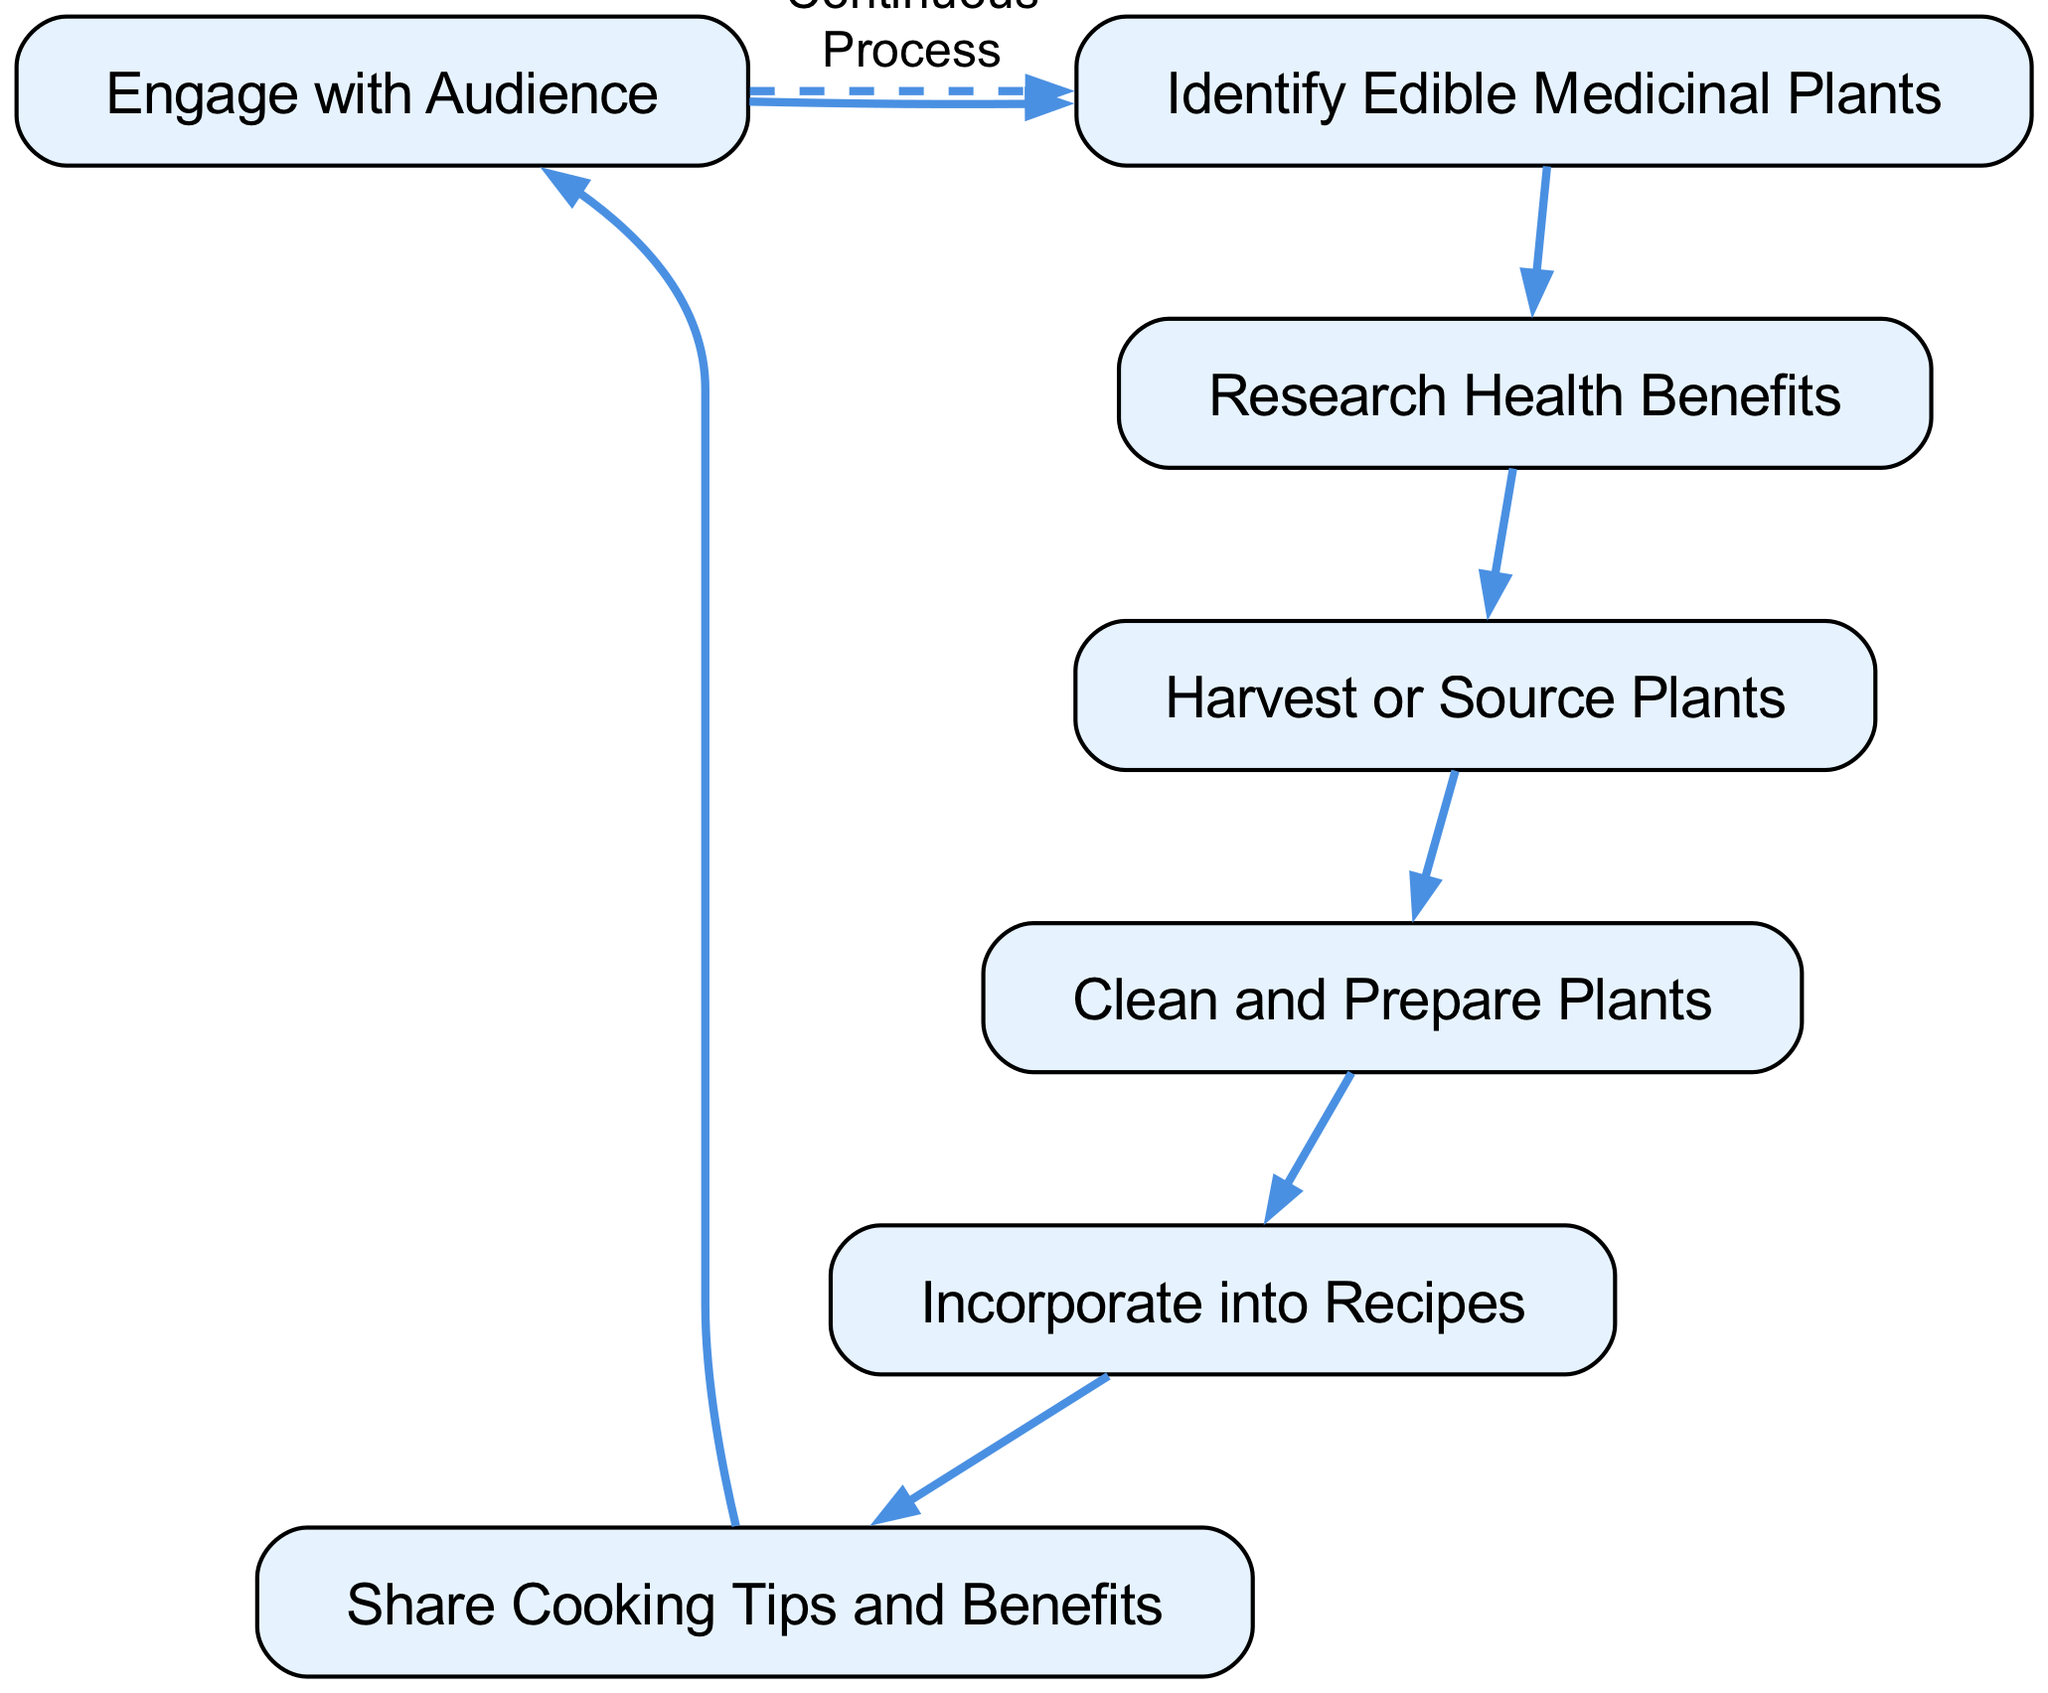What is the first step in the process? The first node in the directed graph is 'Identify Edible Medicinal Plants', indicating that it is the initial step.
Answer: Identify Edible Medicinal Plants How many nodes are present in the diagram? The diagram lists seven distinct nodes representing each step in the process, as enumerated in the provided data.
Answer: 7 Which node follows 'Research Health Benefits'? The directed edge from 'Research Health Benefits' points to 'Harvest or Source Plants', therefore, 'Harvest or Source Plants' is the next step.
Answer: Harvest or Source Plants What is the last step before starting the cycle again? The directed graph shows that 'Engage with Audience' leads back to 'Identify Edible Medicinal Plants', indicating that after sharing cooking tips, the process can restart from the beginning.
Answer: Engage with Audience How many edges are in the diagram? There are six edges connecting the nodes, as specified in the data and seen in the diagram.
Answer: 6 What relationship exists between 'Incorporate into Recipes' and 'Share Cooking Tips and Benefits'? There is a directed connection from 'Incorporate into Recipes' to 'Share Cooking Tips and Benefits', which shows that recipe incorporation directly leads to sharing tips and benefits.
Answer: Direct connection Which node acts as a feedback loop in this process? The node 'Engage with Audience' leads back to 'Identify Edible Medicinal Plants', forming a continuous feedback loop in the process.
Answer: Engage with Audience 